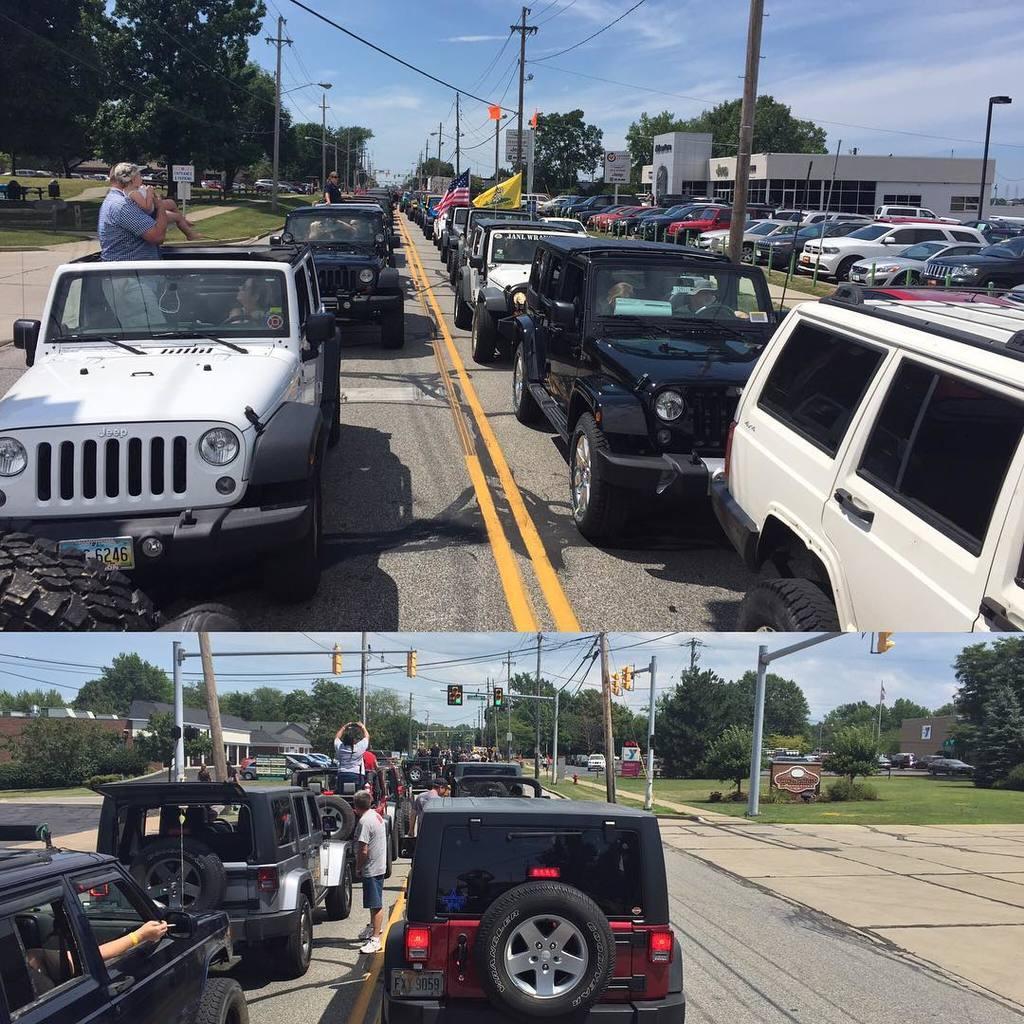What type of artwork is the image? The image is a collage. What natural elements can be seen in the image? Sky, trees, and grass are visible in the image. What man-made structures are present in the image? Poles, wires, a road, houses, traffic signals, and boards are present in the image. What mode of transportation can be seen in the image? Vehicles are present in the image. Are there any people visible in the image? Yes, people are visible in the image. What is the smell of the thumb in the image? There is no thumb present in the image, so it is not possible to determine its smell. What is the wish of the person in the image? There is no indication of a person's wish in the image, as it is a collage of various elements and does not depict a specific scene or situation. 